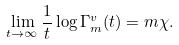<formula> <loc_0><loc_0><loc_500><loc_500>\lim _ { t \to \infty } \frac { 1 } { t } \log \Gamma _ { m } ^ { v } ( t ) = m \chi .</formula> 